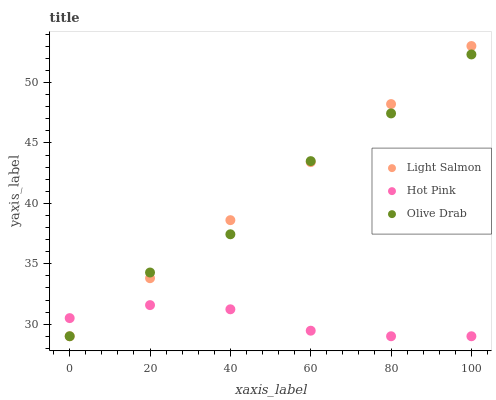Does Hot Pink have the minimum area under the curve?
Answer yes or no. Yes. Does Light Salmon have the maximum area under the curve?
Answer yes or no. Yes. Does Olive Drab have the minimum area under the curve?
Answer yes or no. No. Does Olive Drab have the maximum area under the curve?
Answer yes or no. No. Is Light Salmon the smoothest?
Answer yes or no. Yes. Is Olive Drab the roughest?
Answer yes or no. Yes. Is Hot Pink the smoothest?
Answer yes or no. No. Is Hot Pink the roughest?
Answer yes or no. No. Does Light Salmon have the lowest value?
Answer yes or no. Yes. Does Light Salmon have the highest value?
Answer yes or no. Yes. Does Olive Drab have the highest value?
Answer yes or no. No. Does Hot Pink intersect Light Salmon?
Answer yes or no. Yes. Is Hot Pink less than Light Salmon?
Answer yes or no. No. Is Hot Pink greater than Light Salmon?
Answer yes or no. No. 